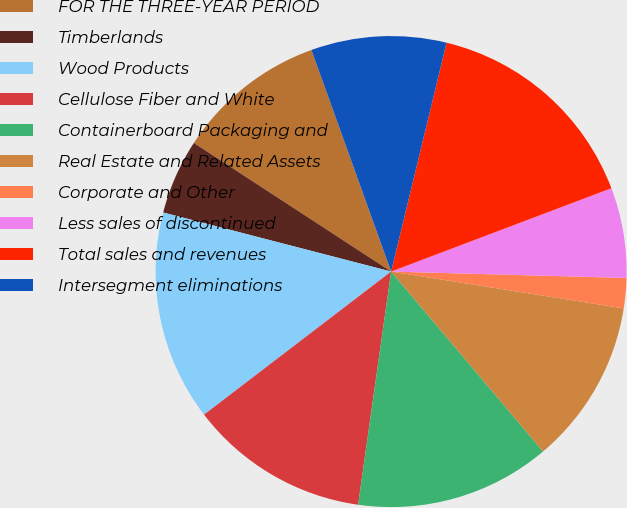<chart> <loc_0><loc_0><loc_500><loc_500><pie_chart><fcel>FOR THE THREE-YEAR PERIOD<fcel>Timberlands<fcel>Wood Products<fcel>Cellulose Fiber and White<fcel>Containerboard Packaging and<fcel>Real Estate and Related Assets<fcel>Corporate and Other<fcel>Less sales of discontinued<fcel>Total sales and revenues<fcel>Intersegment eliminations<nl><fcel>10.31%<fcel>5.16%<fcel>14.43%<fcel>12.37%<fcel>13.4%<fcel>11.34%<fcel>2.07%<fcel>6.19%<fcel>15.46%<fcel>9.28%<nl></chart> 